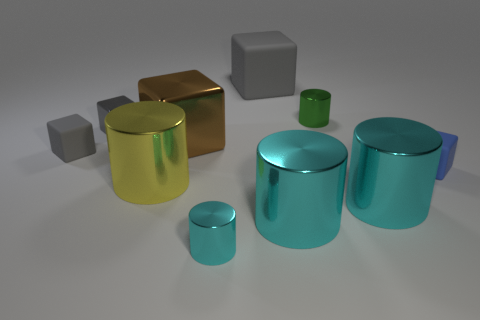How would you interpret the arrangement of the objects in this image? The objects are arranged to showcase a variety of geometric shapes and sizes, seemingly placed in a random manner. This configuration might suggest a study of forms and light, as the positioning allows light to cast both shadows and highlights uniquely on each object, highlighting their material properties and spatial relations. 